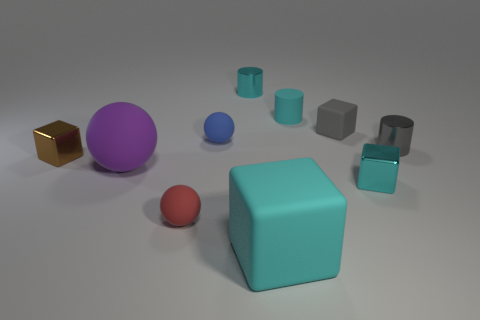The tiny thing that is behind the cyan matte object on the right side of the large rubber object right of the large sphere is what color?
Your answer should be compact. Cyan. How many yellow objects are small shiny objects or matte cubes?
Ensure brevity in your answer.  0. How many other objects are there of the same size as the brown metallic object?
Make the answer very short. 7. What number of rubber objects are there?
Provide a short and direct response. 6. Is there anything else that has the same shape as the blue matte object?
Provide a succinct answer. Yes. Do the small gray thing that is on the left side of the cyan shiny cube and the ball that is in front of the purple object have the same material?
Offer a terse response. Yes. What is the gray cylinder made of?
Provide a succinct answer. Metal. How many tiny purple balls are made of the same material as the large cyan object?
Make the answer very short. 0. How many matte objects are either blue spheres or large purple cylinders?
Your answer should be compact. 1. There is a cyan metal thing that is behind the tiny cyan shiny cube; does it have the same shape as the tiny shiny object that is on the left side of the tiny blue matte object?
Make the answer very short. No. 